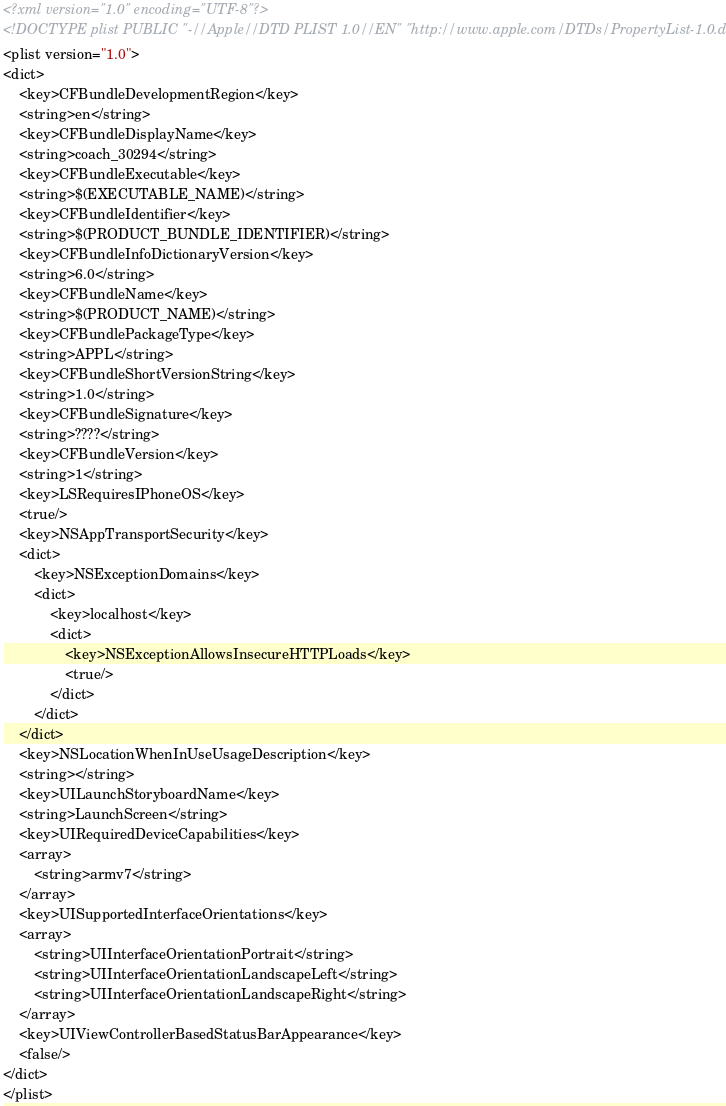<code> <loc_0><loc_0><loc_500><loc_500><_XML_><?xml version="1.0" encoding="UTF-8"?>
<!DOCTYPE plist PUBLIC "-//Apple//DTD PLIST 1.0//EN" "http://www.apple.com/DTDs/PropertyList-1.0.dtd">
<plist version="1.0">
<dict>
	<key>CFBundleDevelopmentRegion</key>
	<string>en</string>
	<key>CFBundleDisplayName</key>
	<string>coach_30294</string>
	<key>CFBundleExecutable</key>
	<string>$(EXECUTABLE_NAME)</string>
	<key>CFBundleIdentifier</key>
	<string>$(PRODUCT_BUNDLE_IDENTIFIER)</string>
	<key>CFBundleInfoDictionaryVersion</key>
	<string>6.0</string>
	<key>CFBundleName</key>
	<string>$(PRODUCT_NAME)</string>
	<key>CFBundlePackageType</key>
	<string>APPL</string>
	<key>CFBundleShortVersionString</key>
	<string>1.0</string>
	<key>CFBundleSignature</key>
	<string>????</string>
	<key>CFBundleVersion</key>
	<string>1</string>
	<key>LSRequiresIPhoneOS</key>
	<true/>
	<key>NSAppTransportSecurity</key>
	<dict>
		<key>NSExceptionDomains</key>
		<dict>
			<key>localhost</key>
			<dict>
				<key>NSExceptionAllowsInsecureHTTPLoads</key>
				<true/>
			</dict>
		</dict>
	</dict>
	<key>NSLocationWhenInUseUsageDescription</key>
	<string></string>
	<key>UILaunchStoryboardName</key>
	<string>LaunchScreen</string>
	<key>UIRequiredDeviceCapabilities</key>
	<array>
		<string>armv7</string>
	</array>
	<key>UISupportedInterfaceOrientations</key>
	<array>
		<string>UIInterfaceOrientationPortrait</string>
		<string>UIInterfaceOrientationLandscapeLeft</string>
		<string>UIInterfaceOrientationLandscapeRight</string>
	</array>
	<key>UIViewControllerBasedStatusBarAppearance</key>
	<false/>
</dict>
</plist>
</code> 